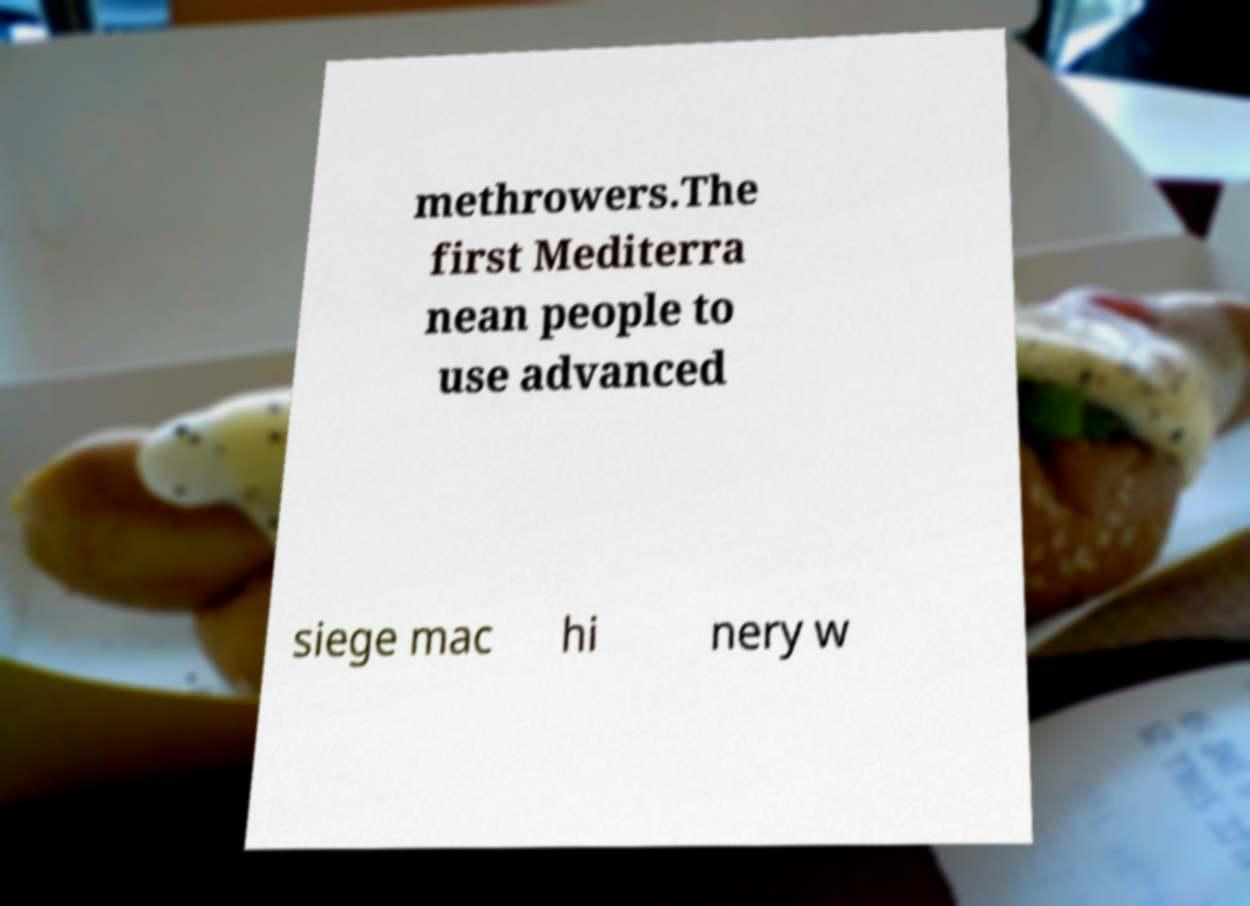Can you accurately transcribe the text from the provided image for me? methrowers.The first Mediterra nean people to use advanced siege mac hi nery w 